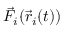<formula> <loc_0><loc_0><loc_500><loc_500>\vec { F } _ { i } ( \vec { r } _ { i } ( t ) )</formula> 